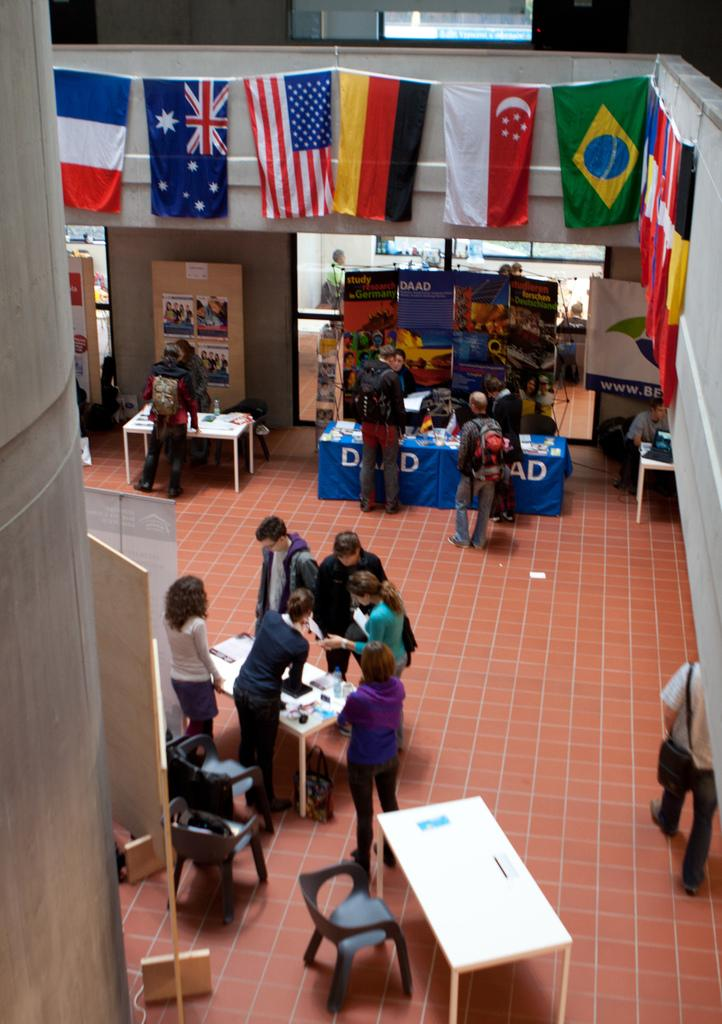Where was the image taken? The image was taken inside a hall. What can be seen in terms of people in the image? There are many people standing in the image. What type of furniture is present in the image? Chairs and tables are present in the image. What decorations can be seen on the walls in the image? Flags are hung on the walls. What is visible in the background of the image? There is a banner in the background of the image. What type of nerve is visible in the image? There is no nerve visible in the image; it is taken inside a hall with people, furniture, flags, and a banner. 